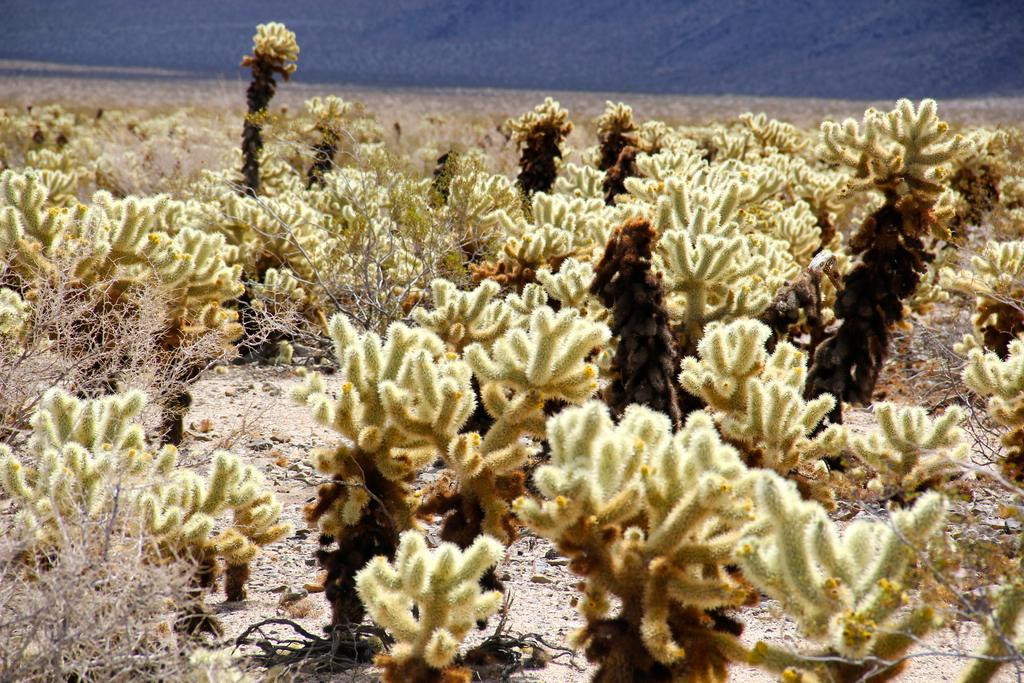What type of plants can be seen in the image? The image contains small plants. What is visible at the bottom of the image? There is ground visible at the bottom of the image. What can be seen in the background of the image? There is water in the background of the image. Are there any plants that appear to be dead or withered in the image? Yes, there are dried plants in the image. What note is the farmer playing on his guitar in the image? There is no farmer or guitar present in the image. 